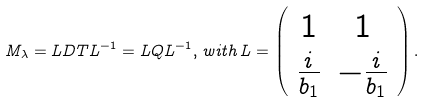<formula> <loc_0><loc_0><loc_500><loc_500>M _ { \lambda } = L D T L ^ { - 1 } = L Q L ^ { - 1 } , \, w i t h \, L = \left ( \begin{array} { c c } 1 & 1 \\ \frac { i } { b _ { 1 } } & - \frac { i } { b _ { 1 } } \\ \end{array} \right ) .</formula> 